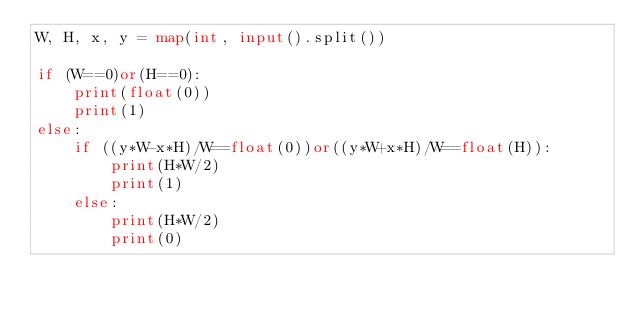Convert code to text. <code><loc_0><loc_0><loc_500><loc_500><_Python_>W, H, x, y = map(int, input().split())

if (W==0)or(H==0):
    print(float(0))
    print(1)
else:
    if ((y*W-x*H)/W==float(0))or((y*W+x*H)/W==float(H)):
        print(H*W/2)
        print(1)
    else:
        print(H*W/2)
        print(0)</code> 